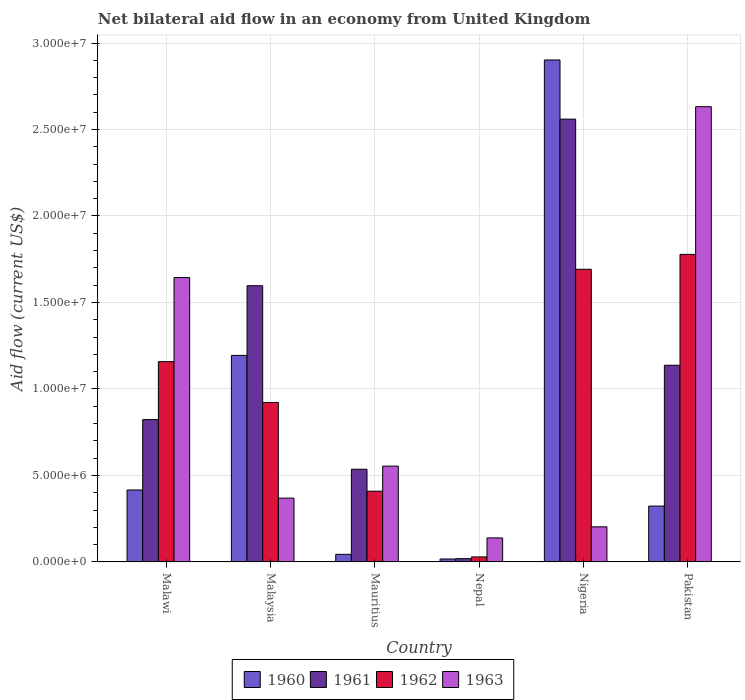How many different coloured bars are there?
Provide a succinct answer. 4. How many groups of bars are there?
Offer a terse response. 6. Are the number of bars per tick equal to the number of legend labels?
Provide a succinct answer. Yes. Are the number of bars on each tick of the X-axis equal?
Offer a terse response. Yes. How many bars are there on the 3rd tick from the right?
Make the answer very short. 4. What is the label of the 6th group of bars from the left?
Offer a terse response. Pakistan. Across all countries, what is the maximum net bilateral aid flow in 1963?
Offer a terse response. 2.63e+07. Across all countries, what is the minimum net bilateral aid flow in 1963?
Keep it short and to the point. 1.39e+06. In which country was the net bilateral aid flow in 1960 maximum?
Keep it short and to the point. Nigeria. In which country was the net bilateral aid flow in 1961 minimum?
Make the answer very short. Nepal. What is the total net bilateral aid flow in 1962 in the graph?
Your response must be concise. 5.99e+07. What is the difference between the net bilateral aid flow in 1962 in Mauritius and that in Nigeria?
Offer a terse response. -1.28e+07. What is the difference between the net bilateral aid flow in 1961 in Nepal and the net bilateral aid flow in 1962 in Pakistan?
Your answer should be very brief. -1.76e+07. What is the average net bilateral aid flow in 1961 per country?
Offer a terse response. 1.11e+07. What is the difference between the net bilateral aid flow of/in 1960 and net bilateral aid flow of/in 1961 in Nigeria?
Your answer should be compact. 3.42e+06. What is the ratio of the net bilateral aid flow in 1960 in Mauritius to that in Pakistan?
Provide a succinct answer. 0.14. Is the net bilateral aid flow in 1962 in Mauritius less than that in Pakistan?
Your response must be concise. Yes. What is the difference between the highest and the second highest net bilateral aid flow in 1961?
Provide a short and direct response. 1.42e+07. What is the difference between the highest and the lowest net bilateral aid flow in 1962?
Ensure brevity in your answer.  1.75e+07. In how many countries, is the net bilateral aid flow in 1962 greater than the average net bilateral aid flow in 1962 taken over all countries?
Your answer should be compact. 3. Is the sum of the net bilateral aid flow in 1962 in Malawi and Malaysia greater than the maximum net bilateral aid flow in 1963 across all countries?
Give a very brief answer. No. Is it the case that in every country, the sum of the net bilateral aid flow in 1961 and net bilateral aid flow in 1963 is greater than the sum of net bilateral aid flow in 1962 and net bilateral aid flow in 1960?
Your answer should be compact. No. How many bars are there?
Offer a terse response. 24. Are all the bars in the graph horizontal?
Give a very brief answer. No. What is the difference between two consecutive major ticks on the Y-axis?
Your answer should be compact. 5.00e+06. Are the values on the major ticks of Y-axis written in scientific E-notation?
Ensure brevity in your answer.  Yes. How many legend labels are there?
Your answer should be compact. 4. What is the title of the graph?
Give a very brief answer. Net bilateral aid flow in an economy from United Kingdom. Does "1979" appear as one of the legend labels in the graph?
Give a very brief answer. No. What is the label or title of the Y-axis?
Provide a short and direct response. Aid flow (current US$). What is the Aid flow (current US$) in 1960 in Malawi?
Your answer should be compact. 4.16e+06. What is the Aid flow (current US$) of 1961 in Malawi?
Provide a short and direct response. 8.23e+06. What is the Aid flow (current US$) of 1962 in Malawi?
Your response must be concise. 1.16e+07. What is the Aid flow (current US$) in 1963 in Malawi?
Offer a very short reply. 1.64e+07. What is the Aid flow (current US$) in 1960 in Malaysia?
Your answer should be compact. 1.19e+07. What is the Aid flow (current US$) of 1961 in Malaysia?
Your response must be concise. 1.60e+07. What is the Aid flow (current US$) of 1962 in Malaysia?
Your answer should be very brief. 9.22e+06. What is the Aid flow (current US$) of 1963 in Malaysia?
Your response must be concise. 3.69e+06. What is the Aid flow (current US$) of 1960 in Mauritius?
Give a very brief answer. 4.40e+05. What is the Aid flow (current US$) of 1961 in Mauritius?
Your response must be concise. 5.36e+06. What is the Aid flow (current US$) of 1962 in Mauritius?
Your answer should be very brief. 4.09e+06. What is the Aid flow (current US$) of 1963 in Mauritius?
Keep it short and to the point. 5.54e+06. What is the Aid flow (current US$) in 1961 in Nepal?
Keep it short and to the point. 1.90e+05. What is the Aid flow (current US$) in 1962 in Nepal?
Provide a short and direct response. 2.90e+05. What is the Aid flow (current US$) of 1963 in Nepal?
Make the answer very short. 1.39e+06. What is the Aid flow (current US$) in 1960 in Nigeria?
Provide a succinct answer. 2.90e+07. What is the Aid flow (current US$) in 1961 in Nigeria?
Your response must be concise. 2.56e+07. What is the Aid flow (current US$) of 1962 in Nigeria?
Offer a terse response. 1.69e+07. What is the Aid flow (current US$) in 1963 in Nigeria?
Your answer should be compact. 2.03e+06. What is the Aid flow (current US$) in 1960 in Pakistan?
Offer a terse response. 3.23e+06. What is the Aid flow (current US$) in 1961 in Pakistan?
Ensure brevity in your answer.  1.14e+07. What is the Aid flow (current US$) of 1962 in Pakistan?
Keep it short and to the point. 1.78e+07. What is the Aid flow (current US$) in 1963 in Pakistan?
Your answer should be compact. 2.63e+07. Across all countries, what is the maximum Aid flow (current US$) in 1960?
Your response must be concise. 2.90e+07. Across all countries, what is the maximum Aid flow (current US$) in 1961?
Provide a succinct answer. 2.56e+07. Across all countries, what is the maximum Aid flow (current US$) in 1962?
Your answer should be very brief. 1.78e+07. Across all countries, what is the maximum Aid flow (current US$) in 1963?
Keep it short and to the point. 2.63e+07. Across all countries, what is the minimum Aid flow (current US$) of 1962?
Provide a short and direct response. 2.90e+05. Across all countries, what is the minimum Aid flow (current US$) of 1963?
Give a very brief answer. 1.39e+06. What is the total Aid flow (current US$) of 1960 in the graph?
Keep it short and to the point. 4.90e+07. What is the total Aid flow (current US$) of 1961 in the graph?
Provide a succinct answer. 6.67e+07. What is the total Aid flow (current US$) of 1962 in the graph?
Provide a succinct answer. 5.99e+07. What is the total Aid flow (current US$) of 1963 in the graph?
Keep it short and to the point. 5.54e+07. What is the difference between the Aid flow (current US$) of 1960 in Malawi and that in Malaysia?
Offer a terse response. -7.78e+06. What is the difference between the Aid flow (current US$) of 1961 in Malawi and that in Malaysia?
Give a very brief answer. -7.74e+06. What is the difference between the Aid flow (current US$) of 1962 in Malawi and that in Malaysia?
Provide a short and direct response. 2.36e+06. What is the difference between the Aid flow (current US$) in 1963 in Malawi and that in Malaysia?
Provide a short and direct response. 1.28e+07. What is the difference between the Aid flow (current US$) of 1960 in Malawi and that in Mauritius?
Give a very brief answer. 3.72e+06. What is the difference between the Aid flow (current US$) in 1961 in Malawi and that in Mauritius?
Provide a short and direct response. 2.87e+06. What is the difference between the Aid flow (current US$) of 1962 in Malawi and that in Mauritius?
Provide a succinct answer. 7.49e+06. What is the difference between the Aid flow (current US$) in 1963 in Malawi and that in Mauritius?
Provide a short and direct response. 1.09e+07. What is the difference between the Aid flow (current US$) in 1960 in Malawi and that in Nepal?
Offer a very short reply. 3.99e+06. What is the difference between the Aid flow (current US$) in 1961 in Malawi and that in Nepal?
Provide a short and direct response. 8.04e+06. What is the difference between the Aid flow (current US$) in 1962 in Malawi and that in Nepal?
Make the answer very short. 1.13e+07. What is the difference between the Aid flow (current US$) of 1963 in Malawi and that in Nepal?
Your response must be concise. 1.50e+07. What is the difference between the Aid flow (current US$) in 1960 in Malawi and that in Nigeria?
Provide a short and direct response. -2.49e+07. What is the difference between the Aid flow (current US$) in 1961 in Malawi and that in Nigeria?
Provide a succinct answer. -1.74e+07. What is the difference between the Aid flow (current US$) in 1962 in Malawi and that in Nigeria?
Your response must be concise. -5.34e+06. What is the difference between the Aid flow (current US$) of 1963 in Malawi and that in Nigeria?
Offer a very short reply. 1.44e+07. What is the difference between the Aid flow (current US$) in 1960 in Malawi and that in Pakistan?
Make the answer very short. 9.30e+05. What is the difference between the Aid flow (current US$) of 1961 in Malawi and that in Pakistan?
Your answer should be compact. -3.14e+06. What is the difference between the Aid flow (current US$) of 1962 in Malawi and that in Pakistan?
Keep it short and to the point. -6.20e+06. What is the difference between the Aid flow (current US$) in 1963 in Malawi and that in Pakistan?
Offer a terse response. -9.88e+06. What is the difference between the Aid flow (current US$) in 1960 in Malaysia and that in Mauritius?
Your answer should be compact. 1.15e+07. What is the difference between the Aid flow (current US$) in 1961 in Malaysia and that in Mauritius?
Your response must be concise. 1.06e+07. What is the difference between the Aid flow (current US$) of 1962 in Malaysia and that in Mauritius?
Provide a short and direct response. 5.13e+06. What is the difference between the Aid flow (current US$) of 1963 in Malaysia and that in Mauritius?
Your answer should be compact. -1.85e+06. What is the difference between the Aid flow (current US$) of 1960 in Malaysia and that in Nepal?
Provide a succinct answer. 1.18e+07. What is the difference between the Aid flow (current US$) in 1961 in Malaysia and that in Nepal?
Give a very brief answer. 1.58e+07. What is the difference between the Aid flow (current US$) in 1962 in Malaysia and that in Nepal?
Your answer should be very brief. 8.93e+06. What is the difference between the Aid flow (current US$) in 1963 in Malaysia and that in Nepal?
Your response must be concise. 2.30e+06. What is the difference between the Aid flow (current US$) in 1960 in Malaysia and that in Nigeria?
Ensure brevity in your answer.  -1.71e+07. What is the difference between the Aid flow (current US$) of 1961 in Malaysia and that in Nigeria?
Provide a succinct answer. -9.63e+06. What is the difference between the Aid flow (current US$) of 1962 in Malaysia and that in Nigeria?
Make the answer very short. -7.70e+06. What is the difference between the Aid flow (current US$) of 1963 in Malaysia and that in Nigeria?
Your answer should be compact. 1.66e+06. What is the difference between the Aid flow (current US$) in 1960 in Malaysia and that in Pakistan?
Give a very brief answer. 8.71e+06. What is the difference between the Aid flow (current US$) of 1961 in Malaysia and that in Pakistan?
Ensure brevity in your answer.  4.60e+06. What is the difference between the Aid flow (current US$) of 1962 in Malaysia and that in Pakistan?
Provide a short and direct response. -8.56e+06. What is the difference between the Aid flow (current US$) of 1963 in Malaysia and that in Pakistan?
Provide a succinct answer. -2.26e+07. What is the difference between the Aid flow (current US$) in 1960 in Mauritius and that in Nepal?
Ensure brevity in your answer.  2.70e+05. What is the difference between the Aid flow (current US$) of 1961 in Mauritius and that in Nepal?
Keep it short and to the point. 5.17e+06. What is the difference between the Aid flow (current US$) in 1962 in Mauritius and that in Nepal?
Your response must be concise. 3.80e+06. What is the difference between the Aid flow (current US$) in 1963 in Mauritius and that in Nepal?
Your response must be concise. 4.15e+06. What is the difference between the Aid flow (current US$) in 1960 in Mauritius and that in Nigeria?
Keep it short and to the point. -2.86e+07. What is the difference between the Aid flow (current US$) in 1961 in Mauritius and that in Nigeria?
Offer a very short reply. -2.02e+07. What is the difference between the Aid flow (current US$) of 1962 in Mauritius and that in Nigeria?
Ensure brevity in your answer.  -1.28e+07. What is the difference between the Aid flow (current US$) of 1963 in Mauritius and that in Nigeria?
Your answer should be compact. 3.51e+06. What is the difference between the Aid flow (current US$) of 1960 in Mauritius and that in Pakistan?
Keep it short and to the point. -2.79e+06. What is the difference between the Aid flow (current US$) of 1961 in Mauritius and that in Pakistan?
Your answer should be very brief. -6.01e+06. What is the difference between the Aid flow (current US$) in 1962 in Mauritius and that in Pakistan?
Provide a short and direct response. -1.37e+07. What is the difference between the Aid flow (current US$) of 1963 in Mauritius and that in Pakistan?
Offer a terse response. -2.08e+07. What is the difference between the Aid flow (current US$) of 1960 in Nepal and that in Nigeria?
Provide a short and direct response. -2.88e+07. What is the difference between the Aid flow (current US$) in 1961 in Nepal and that in Nigeria?
Offer a very short reply. -2.54e+07. What is the difference between the Aid flow (current US$) of 1962 in Nepal and that in Nigeria?
Your answer should be very brief. -1.66e+07. What is the difference between the Aid flow (current US$) of 1963 in Nepal and that in Nigeria?
Your answer should be very brief. -6.40e+05. What is the difference between the Aid flow (current US$) in 1960 in Nepal and that in Pakistan?
Your answer should be very brief. -3.06e+06. What is the difference between the Aid flow (current US$) in 1961 in Nepal and that in Pakistan?
Offer a very short reply. -1.12e+07. What is the difference between the Aid flow (current US$) in 1962 in Nepal and that in Pakistan?
Provide a short and direct response. -1.75e+07. What is the difference between the Aid flow (current US$) in 1963 in Nepal and that in Pakistan?
Make the answer very short. -2.49e+07. What is the difference between the Aid flow (current US$) of 1960 in Nigeria and that in Pakistan?
Keep it short and to the point. 2.58e+07. What is the difference between the Aid flow (current US$) of 1961 in Nigeria and that in Pakistan?
Provide a short and direct response. 1.42e+07. What is the difference between the Aid flow (current US$) in 1962 in Nigeria and that in Pakistan?
Give a very brief answer. -8.60e+05. What is the difference between the Aid flow (current US$) in 1963 in Nigeria and that in Pakistan?
Ensure brevity in your answer.  -2.43e+07. What is the difference between the Aid flow (current US$) of 1960 in Malawi and the Aid flow (current US$) of 1961 in Malaysia?
Your answer should be very brief. -1.18e+07. What is the difference between the Aid flow (current US$) in 1960 in Malawi and the Aid flow (current US$) in 1962 in Malaysia?
Ensure brevity in your answer.  -5.06e+06. What is the difference between the Aid flow (current US$) in 1961 in Malawi and the Aid flow (current US$) in 1962 in Malaysia?
Your response must be concise. -9.90e+05. What is the difference between the Aid flow (current US$) of 1961 in Malawi and the Aid flow (current US$) of 1963 in Malaysia?
Your answer should be very brief. 4.54e+06. What is the difference between the Aid flow (current US$) of 1962 in Malawi and the Aid flow (current US$) of 1963 in Malaysia?
Provide a succinct answer. 7.89e+06. What is the difference between the Aid flow (current US$) of 1960 in Malawi and the Aid flow (current US$) of 1961 in Mauritius?
Your answer should be very brief. -1.20e+06. What is the difference between the Aid flow (current US$) in 1960 in Malawi and the Aid flow (current US$) in 1963 in Mauritius?
Make the answer very short. -1.38e+06. What is the difference between the Aid flow (current US$) of 1961 in Malawi and the Aid flow (current US$) of 1962 in Mauritius?
Give a very brief answer. 4.14e+06. What is the difference between the Aid flow (current US$) in 1961 in Malawi and the Aid flow (current US$) in 1963 in Mauritius?
Provide a short and direct response. 2.69e+06. What is the difference between the Aid flow (current US$) in 1962 in Malawi and the Aid flow (current US$) in 1963 in Mauritius?
Offer a very short reply. 6.04e+06. What is the difference between the Aid flow (current US$) of 1960 in Malawi and the Aid flow (current US$) of 1961 in Nepal?
Keep it short and to the point. 3.97e+06. What is the difference between the Aid flow (current US$) in 1960 in Malawi and the Aid flow (current US$) in 1962 in Nepal?
Your answer should be compact. 3.87e+06. What is the difference between the Aid flow (current US$) of 1960 in Malawi and the Aid flow (current US$) of 1963 in Nepal?
Your answer should be compact. 2.77e+06. What is the difference between the Aid flow (current US$) of 1961 in Malawi and the Aid flow (current US$) of 1962 in Nepal?
Provide a short and direct response. 7.94e+06. What is the difference between the Aid flow (current US$) in 1961 in Malawi and the Aid flow (current US$) in 1963 in Nepal?
Your answer should be very brief. 6.84e+06. What is the difference between the Aid flow (current US$) in 1962 in Malawi and the Aid flow (current US$) in 1963 in Nepal?
Offer a very short reply. 1.02e+07. What is the difference between the Aid flow (current US$) of 1960 in Malawi and the Aid flow (current US$) of 1961 in Nigeria?
Provide a short and direct response. -2.14e+07. What is the difference between the Aid flow (current US$) of 1960 in Malawi and the Aid flow (current US$) of 1962 in Nigeria?
Your response must be concise. -1.28e+07. What is the difference between the Aid flow (current US$) of 1960 in Malawi and the Aid flow (current US$) of 1963 in Nigeria?
Offer a very short reply. 2.13e+06. What is the difference between the Aid flow (current US$) in 1961 in Malawi and the Aid flow (current US$) in 1962 in Nigeria?
Keep it short and to the point. -8.69e+06. What is the difference between the Aid flow (current US$) in 1961 in Malawi and the Aid flow (current US$) in 1963 in Nigeria?
Provide a short and direct response. 6.20e+06. What is the difference between the Aid flow (current US$) of 1962 in Malawi and the Aid flow (current US$) of 1963 in Nigeria?
Provide a short and direct response. 9.55e+06. What is the difference between the Aid flow (current US$) of 1960 in Malawi and the Aid flow (current US$) of 1961 in Pakistan?
Offer a terse response. -7.21e+06. What is the difference between the Aid flow (current US$) in 1960 in Malawi and the Aid flow (current US$) in 1962 in Pakistan?
Provide a short and direct response. -1.36e+07. What is the difference between the Aid flow (current US$) in 1960 in Malawi and the Aid flow (current US$) in 1963 in Pakistan?
Keep it short and to the point. -2.22e+07. What is the difference between the Aid flow (current US$) in 1961 in Malawi and the Aid flow (current US$) in 1962 in Pakistan?
Make the answer very short. -9.55e+06. What is the difference between the Aid flow (current US$) in 1961 in Malawi and the Aid flow (current US$) in 1963 in Pakistan?
Provide a succinct answer. -1.81e+07. What is the difference between the Aid flow (current US$) of 1962 in Malawi and the Aid flow (current US$) of 1963 in Pakistan?
Offer a terse response. -1.47e+07. What is the difference between the Aid flow (current US$) in 1960 in Malaysia and the Aid flow (current US$) in 1961 in Mauritius?
Your answer should be very brief. 6.58e+06. What is the difference between the Aid flow (current US$) in 1960 in Malaysia and the Aid flow (current US$) in 1962 in Mauritius?
Give a very brief answer. 7.85e+06. What is the difference between the Aid flow (current US$) of 1960 in Malaysia and the Aid flow (current US$) of 1963 in Mauritius?
Give a very brief answer. 6.40e+06. What is the difference between the Aid flow (current US$) of 1961 in Malaysia and the Aid flow (current US$) of 1962 in Mauritius?
Provide a succinct answer. 1.19e+07. What is the difference between the Aid flow (current US$) of 1961 in Malaysia and the Aid flow (current US$) of 1963 in Mauritius?
Ensure brevity in your answer.  1.04e+07. What is the difference between the Aid flow (current US$) in 1962 in Malaysia and the Aid flow (current US$) in 1963 in Mauritius?
Offer a terse response. 3.68e+06. What is the difference between the Aid flow (current US$) in 1960 in Malaysia and the Aid flow (current US$) in 1961 in Nepal?
Ensure brevity in your answer.  1.18e+07. What is the difference between the Aid flow (current US$) in 1960 in Malaysia and the Aid flow (current US$) in 1962 in Nepal?
Make the answer very short. 1.16e+07. What is the difference between the Aid flow (current US$) in 1960 in Malaysia and the Aid flow (current US$) in 1963 in Nepal?
Ensure brevity in your answer.  1.06e+07. What is the difference between the Aid flow (current US$) of 1961 in Malaysia and the Aid flow (current US$) of 1962 in Nepal?
Your answer should be very brief. 1.57e+07. What is the difference between the Aid flow (current US$) of 1961 in Malaysia and the Aid flow (current US$) of 1963 in Nepal?
Your answer should be compact. 1.46e+07. What is the difference between the Aid flow (current US$) of 1962 in Malaysia and the Aid flow (current US$) of 1963 in Nepal?
Your answer should be compact. 7.83e+06. What is the difference between the Aid flow (current US$) of 1960 in Malaysia and the Aid flow (current US$) of 1961 in Nigeria?
Your answer should be compact. -1.37e+07. What is the difference between the Aid flow (current US$) in 1960 in Malaysia and the Aid flow (current US$) in 1962 in Nigeria?
Give a very brief answer. -4.98e+06. What is the difference between the Aid flow (current US$) of 1960 in Malaysia and the Aid flow (current US$) of 1963 in Nigeria?
Your answer should be very brief. 9.91e+06. What is the difference between the Aid flow (current US$) in 1961 in Malaysia and the Aid flow (current US$) in 1962 in Nigeria?
Keep it short and to the point. -9.50e+05. What is the difference between the Aid flow (current US$) in 1961 in Malaysia and the Aid flow (current US$) in 1963 in Nigeria?
Keep it short and to the point. 1.39e+07. What is the difference between the Aid flow (current US$) of 1962 in Malaysia and the Aid flow (current US$) of 1963 in Nigeria?
Make the answer very short. 7.19e+06. What is the difference between the Aid flow (current US$) in 1960 in Malaysia and the Aid flow (current US$) in 1961 in Pakistan?
Offer a very short reply. 5.70e+05. What is the difference between the Aid flow (current US$) of 1960 in Malaysia and the Aid flow (current US$) of 1962 in Pakistan?
Offer a very short reply. -5.84e+06. What is the difference between the Aid flow (current US$) of 1960 in Malaysia and the Aid flow (current US$) of 1963 in Pakistan?
Give a very brief answer. -1.44e+07. What is the difference between the Aid flow (current US$) in 1961 in Malaysia and the Aid flow (current US$) in 1962 in Pakistan?
Give a very brief answer. -1.81e+06. What is the difference between the Aid flow (current US$) of 1961 in Malaysia and the Aid flow (current US$) of 1963 in Pakistan?
Make the answer very short. -1.04e+07. What is the difference between the Aid flow (current US$) of 1962 in Malaysia and the Aid flow (current US$) of 1963 in Pakistan?
Provide a short and direct response. -1.71e+07. What is the difference between the Aid flow (current US$) of 1960 in Mauritius and the Aid flow (current US$) of 1962 in Nepal?
Offer a very short reply. 1.50e+05. What is the difference between the Aid flow (current US$) of 1960 in Mauritius and the Aid flow (current US$) of 1963 in Nepal?
Provide a short and direct response. -9.50e+05. What is the difference between the Aid flow (current US$) of 1961 in Mauritius and the Aid flow (current US$) of 1962 in Nepal?
Make the answer very short. 5.07e+06. What is the difference between the Aid flow (current US$) of 1961 in Mauritius and the Aid flow (current US$) of 1963 in Nepal?
Your response must be concise. 3.97e+06. What is the difference between the Aid flow (current US$) of 1962 in Mauritius and the Aid flow (current US$) of 1963 in Nepal?
Give a very brief answer. 2.70e+06. What is the difference between the Aid flow (current US$) in 1960 in Mauritius and the Aid flow (current US$) in 1961 in Nigeria?
Your answer should be compact. -2.52e+07. What is the difference between the Aid flow (current US$) of 1960 in Mauritius and the Aid flow (current US$) of 1962 in Nigeria?
Offer a very short reply. -1.65e+07. What is the difference between the Aid flow (current US$) in 1960 in Mauritius and the Aid flow (current US$) in 1963 in Nigeria?
Give a very brief answer. -1.59e+06. What is the difference between the Aid flow (current US$) in 1961 in Mauritius and the Aid flow (current US$) in 1962 in Nigeria?
Offer a very short reply. -1.16e+07. What is the difference between the Aid flow (current US$) in 1961 in Mauritius and the Aid flow (current US$) in 1963 in Nigeria?
Keep it short and to the point. 3.33e+06. What is the difference between the Aid flow (current US$) in 1962 in Mauritius and the Aid flow (current US$) in 1963 in Nigeria?
Give a very brief answer. 2.06e+06. What is the difference between the Aid flow (current US$) of 1960 in Mauritius and the Aid flow (current US$) of 1961 in Pakistan?
Make the answer very short. -1.09e+07. What is the difference between the Aid flow (current US$) in 1960 in Mauritius and the Aid flow (current US$) in 1962 in Pakistan?
Provide a short and direct response. -1.73e+07. What is the difference between the Aid flow (current US$) of 1960 in Mauritius and the Aid flow (current US$) of 1963 in Pakistan?
Give a very brief answer. -2.59e+07. What is the difference between the Aid flow (current US$) of 1961 in Mauritius and the Aid flow (current US$) of 1962 in Pakistan?
Your answer should be compact. -1.24e+07. What is the difference between the Aid flow (current US$) in 1961 in Mauritius and the Aid flow (current US$) in 1963 in Pakistan?
Your response must be concise. -2.10e+07. What is the difference between the Aid flow (current US$) of 1962 in Mauritius and the Aid flow (current US$) of 1963 in Pakistan?
Your answer should be compact. -2.22e+07. What is the difference between the Aid flow (current US$) of 1960 in Nepal and the Aid flow (current US$) of 1961 in Nigeria?
Offer a terse response. -2.54e+07. What is the difference between the Aid flow (current US$) of 1960 in Nepal and the Aid flow (current US$) of 1962 in Nigeria?
Your answer should be compact. -1.68e+07. What is the difference between the Aid flow (current US$) in 1960 in Nepal and the Aid flow (current US$) in 1963 in Nigeria?
Provide a succinct answer. -1.86e+06. What is the difference between the Aid flow (current US$) of 1961 in Nepal and the Aid flow (current US$) of 1962 in Nigeria?
Your response must be concise. -1.67e+07. What is the difference between the Aid flow (current US$) of 1961 in Nepal and the Aid flow (current US$) of 1963 in Nigeria?
Offer a terse response. -1.84e+06. What is the difference between the Aid flow (current US$) of 1962 in Nepal and the Aid flow (current US$) of 1963 in Nigeria?
Your answer should be compact. -1.74e+06. What is the difference between the Aid flow (current US$) of 1960 in Nepal and the Aid flow (current US$) of 1961 in Pakistan?
Your answer should be compact. -1.12e+07. What is the difference between the Aid flow (current US$) in 1960 in Nepal and the Aid flow (current US$) in 1962 in Pakistan?
Ensure brevity in your answer.  -1.76e+07. What is the difference between the Aid flow (current US$) of 1960 in Nepal and the Aid flow (current US$) of 1963 in Pakistan?
Give a very brief answer. -2.62e+07. What is the difference between the Aid flow (current US$) in 1961 in Nepal and the Aid flow (current US$) in 1962 in Pakistan?
Offer a terse response. -1.76e+07. What is the difference between the Aid flow (current US$) of 1961 in Nepal and the Aid flow (current US$) of 1963 in Pakistan?
Your answer should be compact. -2.61e+07. What is the difference between the Aid flow (current US$) in 1962 in Nepal and the Aid flow (current US$) in 1963 in Pakistan?
Give a very brief answer. -2.60e+07. What is the difference between the Aid flow (current US$) in 1960 in Nigeria and the Aid flow (current US$) in 1961 in Pakistan?
Give a very brief answer. 1.76e+07. What is the difference between the Aid flow (current US$) of 1960 in Nigeria and the Aid flow (current US$) of 1962 in Pakistan?
Offer a terse response. 1.12e+07. What is the difference between the Aid flow (current US$) of 1960 in Nigeria and the Aid flow (current US$) of 1963 in Pakistan?
Provide a succinct answer. 2.70e+06. What is the difference between the Aid flow (current US$) of 1961 in Nigeria and the Aid flow (current US$) of 1962 in Pakistan?
Ensure brevity in your answer.  7.82e+06. What is the difference between the Aid flow (current US$) in 1961 in Nigeria and the Aid flow (current US$) in 1963 in Pakistan?
Make the answer very short. -7.20e+05. What is the difference between the Aid flow (current US$) of 1962 in Nigeria and the Aid flow (current US$) of 1963 in Pakistan?
Your response must be concise. -9.40e+06. What is the average Aid flow (current US$) of 1960 per country?
Keep it short and to the point. 8.16e+06. What is the average Aid flow (current US$) in 1961 per country?
Offer a terse response. 1.11e+07. What is the average Aid flow (current US$) of 1962 per country?
Your answer should be compact. 9.98e+06. What is the average Aid flow (current US$) of 1963 per country?
Ensure brevity in your answer.  9.24e+06. What is the difference between the Aid flow (current US$) of 1960 and Aid flow (current US$) of 1961 in Malawi?
Your answer should be compact. -4.07e+06. What is the difference between the Aid flow (current US$) of 1960 and Aid flow (current US$) of 1962 in Malawi?
Keep it short and to the point. -7.42e+06. What is the difference between the Aid flow (current US$) in 1960 and Aid flow (current US$) in 1963 in Malawi?
Offer a terse response. -1.23e+07. What is the difference between the Aid flow (current US$) in 1961 and Aid flow (current US$) in 1962 in Malawi?
Offer a very short reply. -3.35e+06. What is the difference between the Aid flow (current US$) of 1961 and Aid flow (current US$) of 1963 in Malawi?
Provide a short and direct response. -8.21e+06. What is the difference between the Aid flow (current US$) of 1962 and Aid flow (current US$) of 1963 in Malawi?
Ensure brevity in your answer.  -4.86e+06. What is the difference between the Aid flow (current US$) of 1960 and Aid flow (current US$) of 1961 in Malaysia?
Make the answer very short. -4.03e+06. What is the difference between the Aid flow (current US$) in 1960 and Aid flow (current US$) in 1962 in Malaysia?
Offer a terse response. 2.72e+06. What is the difference between the Aid flow (current US$) of 1960 and Aid flow (current US$) of 1963 in Malaysia?
Give a very brief answer. 8.25e+06. What is the difference between the Aid flow (current US$) of 1961 and Aid flow (current US$) of 1962 in Malaysia?
Offer a very short reply. 6.75e+06. What is the difference between the Aid flow (current US$) of 1961 and Aid flow (current US$) of 1963 in Malaysia?
Provide a succinct answer. 1.23e+07. What is the difference between the Aid flow (current US$) in 1962 and Aid flow (current US$) in 1963 in Malaysia?
Give a very brief answer. 5.53e+06. What is the difference between the Aid flow (current US$) of 1960 and Aid flow (current US$) of 1961 in Mauritius?
Provide a succinct answer. -4.92e+06. What is the difference between the Aid flow (current US$) of 1960 and Aid flow (current US$) of 1962 in Mauritius?
Make the answer very short. -3.65e+06. What is the difference between the Aid flow (current US$) of 1960 and Aid flow (current US$) of 1963 in Mauritius?
Give a very brief answer. -5.10e+06. What is the difference between the Aid flow (current US$) in 1961 and Aid flow (current US$) in 1962 in Mauritius?
Give a very brief answer. 1.27e+06. What is the difference between the Aid flow (current US$) of 1962 and Aid flow (current US$) of 1963 in Mauritius?
Offer a very short reply. -1.45e+06. What is the difference between the Aid flow (current US$) in 1960 and Aid flow (current US$) in 1963 in Nepal?
Ensure brevity in your answer.  -1.22e+06. What is the difference between the Aid flow (current US$) in 1961 and Aid flow (current US$) in 1963 in Nepal?
Ensure brevity in your answer.  -1.20e+06. What is the difference between the Aid flow (current US$) of 1962 and Aid flow (current US$) of 1963 in Nepal?
Provide a succinct answer. -1.10e+06. What is the difference between the Aid flow (current US$) of 1960 and Aid flow (current US$) of 1961 in Nigeria?
Provide a succinct answer. 3.42e+06. What is the difference between the Aid flow (current US$) of 1960 and Aid flow (current US$) of 1962 in Nigeria?
Provide a short and direct response. 1.21e+07. What is the difference between the Aid flow (current US$) in 1960 and Aid flow (current US$) in 1963 in Nigeria?
Make the answer very short. 2.70e+07. What is the difference between the Aid flow (current US$) of 1961 and Aid flow (current US$) of 1962 in Nigeria?
Offer a terse response. 8.68e+06. What is the difference between the Aid flow (current US$) of 1961 and Aid flow (current US$) of 1963 in Nigeria?
Your response must be concise. 2.36e+07. What is the difference between the Aid flow (current US$) of 1962 and Aid flow (current US$) of 1963 in Nigeria?
Your answer should be very brief. 1.49e+07. What is the difference between the Aid flow (current US$) in 1960 and Aid flow (current US$) in 1961 in Pakistan?
Offer a very short reply. -8.14e+06. What is the difference between the Aid flow (current US$) in 1960 and Aid flow (current US$) in 1962 in Pakistan?
Make the answer very short. -1.46e+07. What is the difference between the Aid flow (current US$) in 1960 and Aid flow (current US$) in 1963 in Pakistan?
Your answer should be very brief. -2.31e+07. What is the difference between the Aid flow (current US$) of 1961 and Aid flow (current US$) of 1962 in Pakistan?
Keep it short and to the point. -6.41e+06. What is the difference between the Aid flow (current US$) in 1961 and Aid flow (current US$) in 1963 in Pakistan?
Your answer should be very brief. -1.50e+07. What is the difference between the Aid flow (current US$) in 1962 and Aid flow (current US$) in 1963 in Pakistan?
Your response must be concise. -8.54e+06. What is the ratio of the Aid flow (current US$) of 1960 in Malawi to that in Malaysia?
Your response must be concise. 0.35. What is the ratio of the Aid flow (current US$) in 1961 in Malawi to that in Malaysia?
Offer a very short reply. 0.52. What is the ratio of the Aid flow (current US$) in 1962 in Malawi to that in Malaysia?
Offer a terse response. 1.26. What is the ratio of the Aid flow (current US$) of 1963 in Malawi to that in Malaysia?
Your response must be concise. 4.46. What is the ratio of the Aid flow (current US$) in 1960 in Malawi to that in Mauritius?
Your answer should be compact. 9.45. What is the ratio of the Aid flow (current US$) in 1961 in Malawi to that in Mauritius?
Provide a succinct answer. 1.54. What is the ratio of the Aid flow (current US$) of 1962 in Malawi to that in Mauritius?
Provide a short and direct response. 2.83. What is the ratio of the Aid flow (current US$) of 1963 in Malawi to that in Mauritius?
Make the answer very short. 2.97. What is the ratio of the Aid flow (current US$) of 1960 in Malawi to that in Nepal?
Ensure brevity in your answer.  24.47. What is the ratio of the Aid flow (current US$) of 1961 in Malawi to that in Nepal?
Ensure brevity in your answer.  43.32. What is the ratio of the Aid flow (current US$) in 1962 in Malawi to that in Nepal?
Your response must be concise. 39.93. What is the ratio of the Aid flow (current US$) in 1963 in Malawi to that in Nepal?
Your answer should be very brief. 11.83. What is the ratio of the Aid flow (current US$) in 1960 in Malawi to that in Nigeria?
Provide a succinct answer. 0.14. What is the ratio of the Aid flow (current US$) of 1961 in Malawi to that in Nigeria?
Offer a terse response. 0.32. What is the ratio of the Aid flow (current US$) in 1962 in Malawi to that in Nigeria?
Ensure brevity in your answer.  0.68. What is the ratio of the Aid flow (current US$) of 1963 in Malawi to that in Nigeria?
Offer a terse response. 8.1. What is the ratio of the Aid flow (current US$) in 1960 in Malawi to that in Pakistan?
Offer a very short reply. 1.29. What is the ratio of the Aid flow (current US$) of 1961 in Malawi to that in Pakistan?
Provide a succinct answer. 0.72. What is the ratio of the Aid flow (current US$) of 1962 in Malawi to that in Pakistan?
Give a very brief answer. 0.65. What is the ratio of the Aid flow (current US$) of 1963 in Malawi to that in Pakistan?
Your answer should be very brief. 0.62. What is the ratio of the Aid flow (current US$) of 1960 in Malaysia to that in Mauritius?
Keep it short and to the point. 27.14. What is the ratio of the Aid flow (current US$) of 1961 in Malaysia to that in Mauritius?
Provide a short and direct response. 2.98. What is the ratio of the Aid flow (current US$) of 1962 in Malaysia to that in Mauritius?
Give a very brief answer. 2.25. What is the ratio of the Aid flow (current US$) in 1963 in Malaysia to that in Mauritius?
Give a very brief answer. 0.67. What is the ratio of the Aid flow (current US$) in 1960 in Malaysia to that in Nepal?
Offer a very short reply. 70.24. What is the ratio of the Aid flow (current US$) of 1961 in Malaysia to that in Nepal?
Give a very brief answer. 84.05. What is the ratio of the Aid flow (current US$) of 1962 in Malaysia to that in Nepal?
Provide a succinct answer. 31.79. What is the ratio of the Aid flow (current US$) of 1963 in Malaysia to that in Nepal?
Give a very brief answer. 2.65. What is the ratio of the Aid flow (current US$) in 1960 in Malaysia to that in Nigeria?
Offer a very short reply. 0.41. What is the ratio of the Aid flow (current US$) of 1961 in Malaysia to that in Nigeria?
Make the answer very short. 0.62. What is the ratio of the Aid flow (current US$) of 1962 in Malaysia to that in Nigeria?
Your answer should be very brief. 0.54. What is the ratio of the Aid flow (current US$) of 1963 in Malaysia to that in Nigeria?
Make the answer very short. 1.82. What is the ratio of the Aid flow (current US$) of 1960 in Malaysia to that in Pakistan?
Keep it short and to the point. 3.7. What is the ratio of the Aid flow (current US$) in 1961 in Malaysia to that in Pakistan?
Ensure brevity in your answer.  1.4. What is the ratio of the Aid flow (current US$) in 1962 in Malaysia to that in Pakistan?
Keep it short and to the point. 0.52. What is the ratio of the Aid flow (current US$) in 1963 in Malaysia to that in Pakistan?
Make the answer very short. 0.14. What is the ratio of the Aid flow (current US$) in 1960 in Mauritius to that in Nepal?
Your answer should be very brief. 2.59. What is the ratio of the Aid flow (current US$) in 1961 in Mauritius to that in Nepal?
Your response must be concise. 28.21. What is the ratio of the Aid flow (current US$) of 1962 in Mauritius to that in Nepal?
Your answer should be very brief. 14.1. What is the ratio of the Aid flow (current US$) in 1963 in Mauritius to that in Nepal?
Offer a terse response. 3.99. What is the ratio of the Aid flow (current US$) in 1960 in Mauritius to that in Nigeria?
Offer a terse response. 0.02. What is the ratio of the Aid flow (current US$) in 1961 in Mauritius to that in Nigeria?
Offer a very short reply. 0.21. What is the ratio of the Aid flow (current US$) of 1962 in Mauritius to that in Nigeria?
Your answer should be very brief. 0.24. What is the ratio of the Aid flow (current US$) in 1963 in Mauritius to that in Nigeria?
Ensure brevity in your answer.  2.73. What is the ratio of the Aid flow (current US$) of 1960 in Mauritius to that in Pakistan?
Keep it short and to the point. 0.14. What is the ratio of the Aid flow (current US$) in 1961 in Mauritius to that in Pakistan?
Keep it short and to the point. 0.47. What is the ratio of the Aid flow (current US$) of 1962 in Mauritius to that in Pakistan?
Make the answer very short. 0.23. What is the ratio of the Aid flow (current US$) in 1963 in Mauritius to that in Pakistan?
Your answer should be compact. 0.21. What is the ratio of the Aid flow (current US$) of 1960 in Nepal to that in Nigeria?
Provide a succinct answer. 0.01. What is the ratio of the Aid flow (current US$) in 1961 in Nepal to that in Nigeria?
Keep it short and to the point. 0.01. What is the ratio of the Aid flow (current US$) of 1962 in Nepal to that in Nigeria?
Keep it short and to the point. 0.02. What is the ratio of the Aid flow (current US$) of 1963 in Nepal to that in Nigeria?
Offer a terse response. 0.68. What is the ratio of the Aid flow (current US$) in 1960 in Nepal to that in Pakistan?
Your answer should be very brief. 0.05. What is the ratio of the Aid flow (current US$) in 1961 in Nepal to that in Pakistan?
Ensure brevity in your answer.  0.02. What is the ratio of the Aid flow (current US$) in 1962 in Nepal to that in Pakistan?
Ensure brevity in your answer.  0.02. What is the ratio of the Aid flow (current US$) in 1963 in Nepal to that in Pakistan?
Give a very brief answer. 0.05. What is the ratio of the Aid flow (current US$) in 1960 in Nigeria to that in Pakistan?
Give a very brief answer. 8.98. What is the ratio of the Aid flow (current US$) in 1961 in Nigeria to that in Pakistan?
Give a very brief answer. 2.25. What is the ratio of the Aid flow (current US$) of 1962 in Nigeria to that in Pakistan?
Your response must be concise. 0.95. What is the ratio of the Aid flow (current US$) of 1963 in Nigeria to that in Pakistan?
Keep it short and to the point. 0.08. What is the difference between the highest and the second highest Aid flow (current US$) of 1960?
Your response must be concise. 1.71e+07. What is the difference between the highest and the second highest Aid flow (current US$) of 1961?
Keep it short and to the point. 9.63e+06. What is the difference between the highest and the second highest Aid flow (current US$) in 1962?
Make the answer very short. 8.60e+05. What is the difference between the highest and the second highest Aid flow (current US$) of 1963?
Keep it short and to the point. 9.88e+06. What is the difference between the highest and the lowest Aid flow (current US$) in 1960?
Your answer should be compact. 2.88e+07. What is the difference between the highest and the lowest Aid flow (current US$) of 1961?
Keep it short and to the point. 2.54e+07. What is the difference between the highest and the lowest Aid flow (current US$) of 1962?
Provide a succinct answer. 1.75e+07. What is the difference between the highest and the lowest Aid flow (current US$) in 1963?
Your response must be concise. 2.49e+07. 